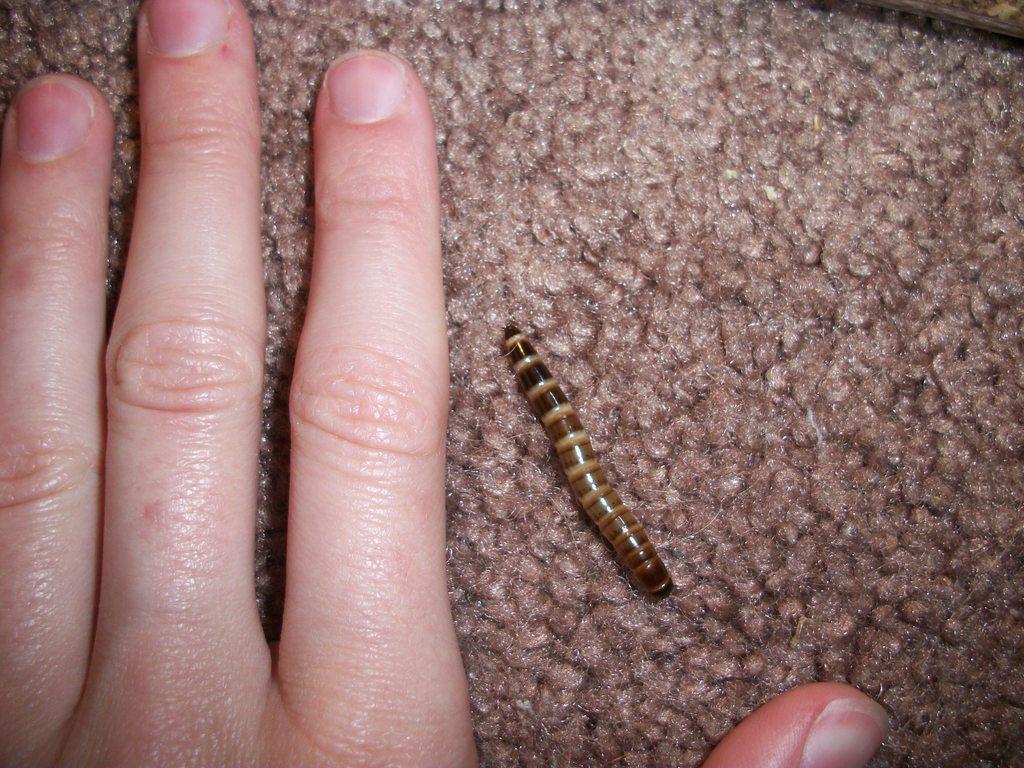In one or two sentences, can you explain what this image depicts? In this image we can see human hand, worm placed on the surface. 